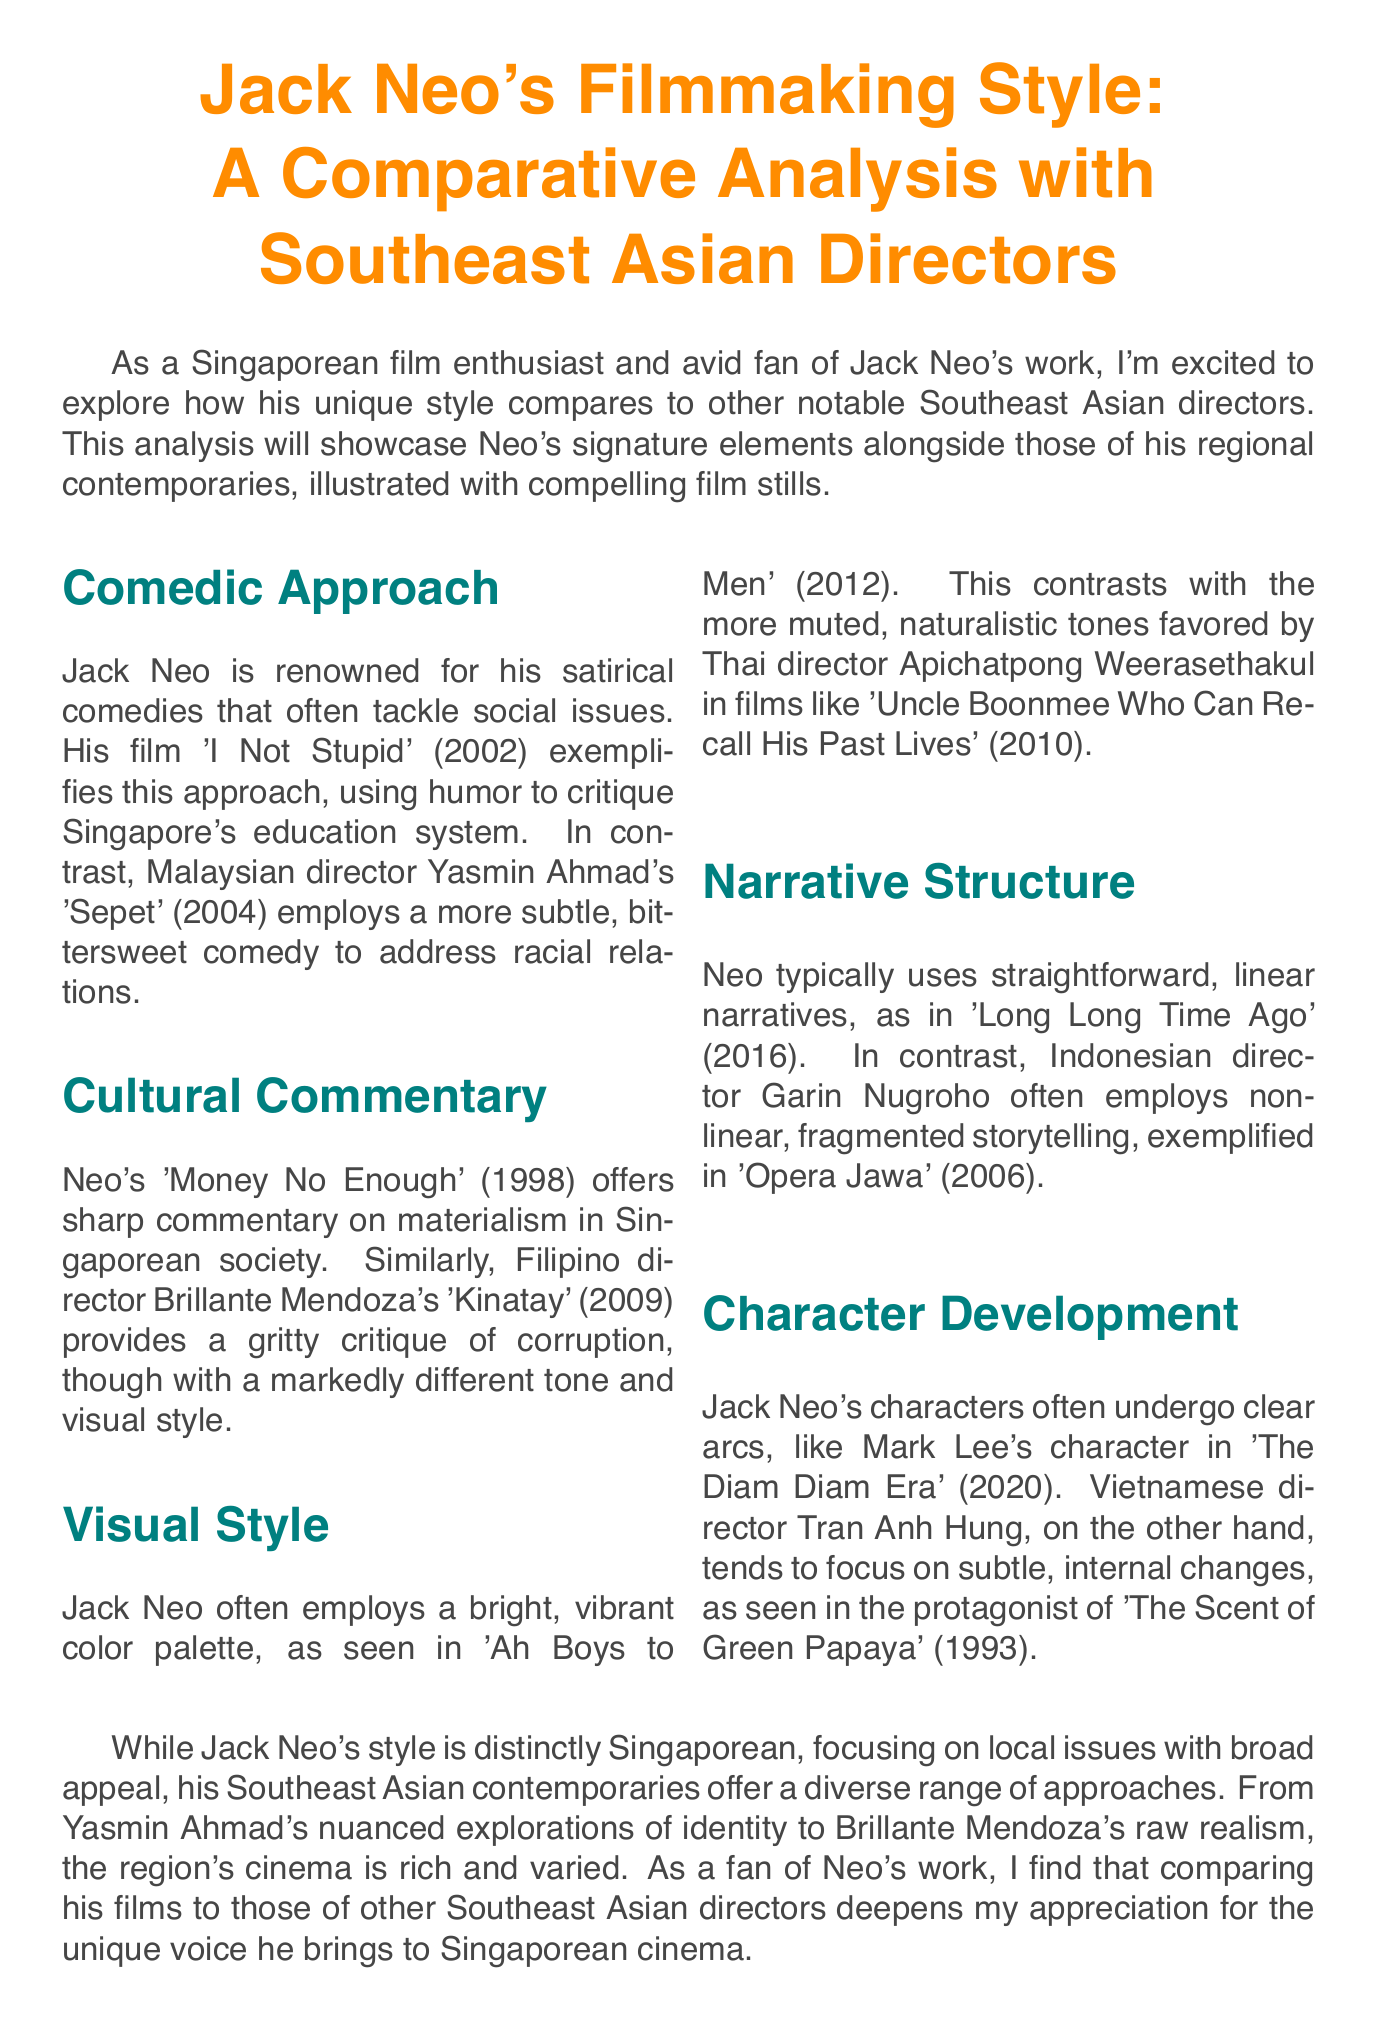what is the title of the newsletter? The title of the newsletter is stated at the beginning of the document.
Answer: Jack Neo's Filmmaking Style: A Comparative Analysis with Southeast Asian Directors who directed 'Sepet'? The document mentions Malaysian director Yasmin Ahmad in relation to the film 'Sepet'.
Answer: Yasmin Ahmad which film illustrates Jack Neo's comedic approach? The document refers to 'I Not Stupid' (2002) as an example of Neo's comedic style.
Answer: I Not Stupid what year was 'Money No Enough' released? The document provides the release year of the film 'Money No Enough' in the cultural commentary section.
Answer: 1998 how does Jack Neo's visual style differ from Thai director Apichatpong Weerasethakul's? The document describes their visual styles, stating that Neo uses a bright and vibrant color palette while Weerasethakul uses muted tones.
Answer: Bright, vibrant vs. muted which director is noted for non-linear storytelling? The document mentions Indonesian director Garin Nugroho in relation to non-linear, fragmented storytelling techniques.
Answer: Garin Nugroho what is the focus of Tran Anh Hung's character development? The document contrasts character arcs in Neo's films with the subtle changes in characters in Hung's films.
Answer: Subtle, internal changes where will the special screening take place? The conclusion of the document states the location for the special screening event.
Answer: The Projector 